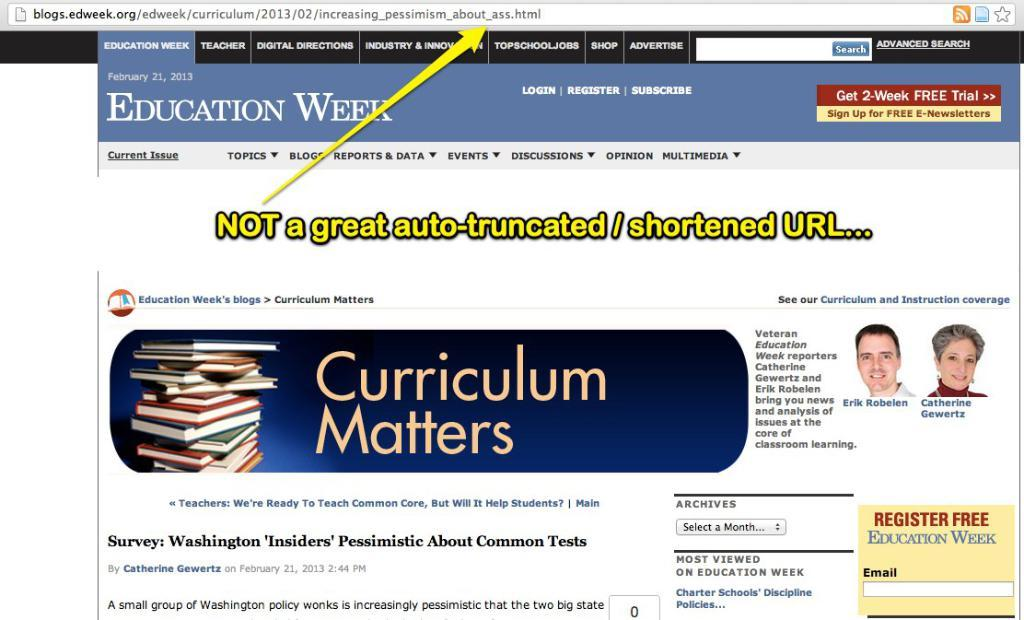<image>
Offer a succinct explanation of the picture presented. A web site says that curriculum matters and has a yellow arrow pointing to the URL. 